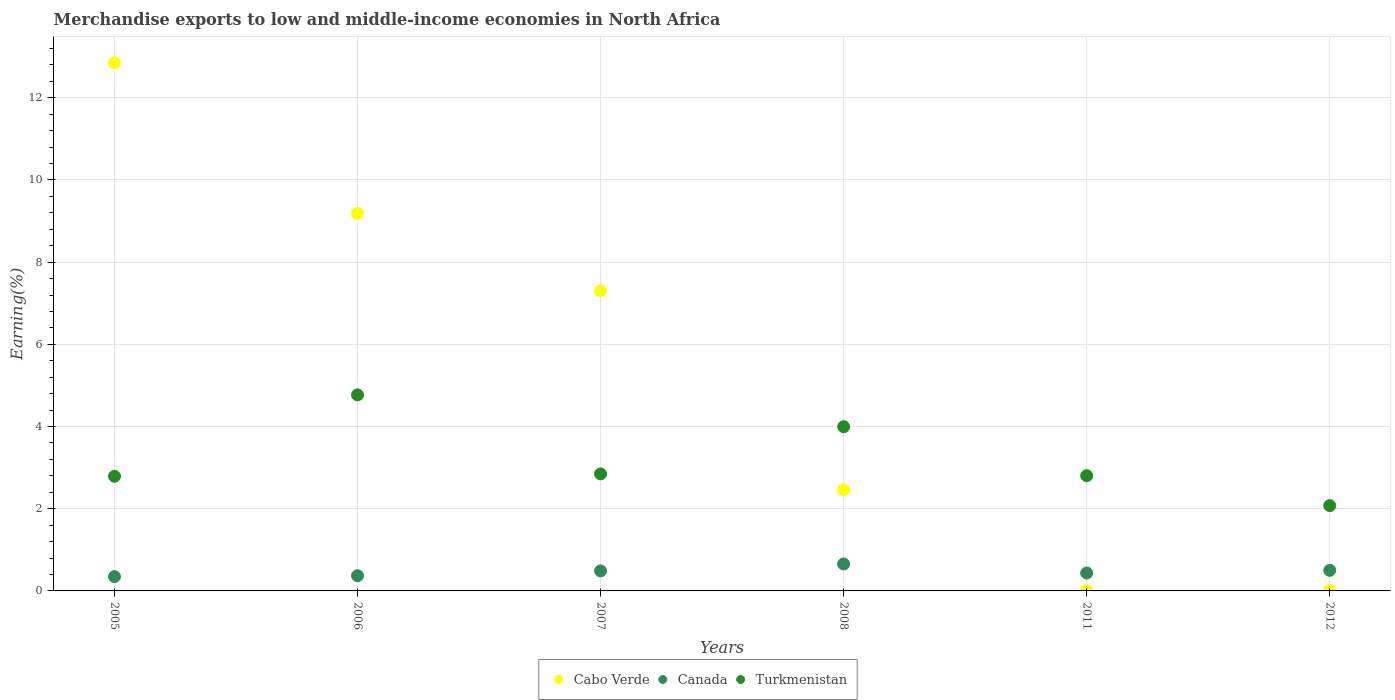How many different coloured dotlines are there?
Make the answer very short. 3. What is the percentage of amount earned from merchandise exports in Canada in 2011?
Your response must be concise. 0.44. Across all years, what is the maximum percentage of amount earned from merchandise exports in Cabo Verde?
Ensure brevity in your answer.  12.85. Across all years, what is the minimum percentage of amount earned from merchandise exports in Canada?
Offer a terse response. 0.35. What is the total percentage of amount earned from merchandise exports in Cabo Verde in the graph?
Make the answer very short. 31.82. What is the difference between the percentage of amount earned from merchandise exports in Canada in 2006 and that in 2011?
Your answer should be compact. -0.07. What is the difference between the percentage of amount earned from merchandise exports in Turkmenistan in 2005 and the percentage of amount earned from merchandise exports in Cabo Verde in 2007?
Your answer should be compact. -4.51. What is the average percentage of amount earned from merchandise exports in Cabo Verde per year?
Offer a terse response. 5.3. In the year 2005, what is the difference between the percentage of amount earned from merchandise exports in Canada and percentage of amount earned from merchandise exports in Cabo Verde?
Keep it short and to the point. -12.5. What is the ratio of the percentage of amount earned from merchandise exports in Cabo Verde in 2007 to that in 2008?
Your answer should be very brief. 2.97. What is the difference between the highest and the second highest percentage of amount earned from merchandise exports in Canada?
Your response must be concise. 0.15. What is the difference between the highest and the lowest percentage of amount earned from merchandise exports in Canada?
Make the answer very short. 0.31. In how many years, is the percentage of amount earned from merchandise exports in Cabo Verde greater than the average percentage of amount earned from merchandise exports in Cabo Verde taken over all years?
Your answer should be very brief. 3. How many years are there in the graph?
Give a very brief answer. 6. What is the difference between two consecutive major ticks on the Y-axis?
Offer a very short reply. 2. Does the graph contain any zero values?
Provide a short and direct response. No. Does the graph contain grids?
Your answer should be compact. Yes. Where does the legend appear in the graph?
Offer a very short reply. Bottom center. What is the title of the graph?
Your response must be concise. Merchandise exports to low and middle-income economies in North Africa. What is the label or title of the Y-axis?
Ensure brevity in your answer.  Earning(%). What is the Earning(%) of Cabo Verde in 2005?
Provide a succinct answer. 12.85. What is the Earning(%) in Canada in 2005?
Your answer should be compact. 0.35. What is the Earning(%) in Turkmenistan in 2005?
Make the answer very short. 2.79. What is the Earning(%) in Cabo Verde in 2006?
Provide a short and direct response. 9.18. What is the Earning(%) of Canada in 2006?
Offer a very short reply. 0.37. What is the Earning(%) in Turkmenistan in 2006?
Ensure brevity in your answer.  4.77. What is the Earning(%) in Cabo Verde in 2007?
Offer a terse response. 7.3. What is the Earning(%) of Canada in 2007?
Offer a terse response. 0.49. What is the Earning(%) of Turkmenistan in 2007?
Your response must be concise. 2.85. What is the Earning(%) in Cabo Verde in 2008?
Ensure brevity in your answer.  2.46. What is the Earning(%) of Canada in 2008?
Offer a very short reply. 0.66. What is the Earning(%) in Turkmenistan in 2008?
Give a very brief answer. 4. What is the Earning(%) in Cabo Verde in 2011?
Make the answer very short. 0.01. What is the Earning(%) in Canada in 2011?
Your answer should be compact. 0.44. What is the Earning(%) of Turkmenistan in 2011?
Offer a very short reply. 2.8. What is the Earning(%) of Cabo Verde in 2012?
Give a very brief answer. 0.01. What is the Earning(%) of Canada in 2012?
Make the answer very short. 0.5. What is the Earning(%) of Turkmenistan in 2012?
Offer a terse response. 2.08. Across all years, what is the maximum Earning(%) in Cabo Verde?
Keep it short and to the point. 12.85. Across all years, what is the maximum Earning(%) of Canada?
Give a very brief answer. 0.66. Across all years, what is the maximum Earning(%) of Turkmenistan?
Offer a terse response. 4.77. Across all years, what is the minimum Earning(%) of Cabo Verde?
Provide a succinct answer. 0.01. Across all years, what is the minimum Earning(%) in Canada?
Your response must be concise. 0.35. Across all years, what is the minimum Earning(%) in Turkmenistan?
Give a very brief answer. 2.08. What is the total Earning(%) of Cabo Verde in the graph?
Ensure brevity in your answer.  31.82. What is the total Earning(%) in Canada in the graph?
Provide a succinct answer. 2.8. What is the total Earning(%) of Turkmenistan in the graph?
Keep it short and to the point. 19.28. What is the difference between the Earning(%) of Cabo Verde in 2005 and that in 2006?
Your answer should be very brief. 3.66. What is the difference between the Earning(%) in Canada in 2005 and that in 2006?
Make the answer very short. -0.02. What is the difference between the Earning(%) in Turkmenistan in 2005 and that in 2006?
Keep it short and to the point. -1.98. What is the difference between the Earning(%) of Cabo Verde in 2005 and that in 2007?
Your answer should be compact. 5.54. What is the difference between the Earning(%) of Canada in 2005 and that in 2007?
Ensure brevity in your answer.  -0.14. What is the difference between the Earning(%) of Turkmenistan in 2005 and that in 2007?
Ensure brevity in your answer.  -0.06. What is the difference between the Earning(%) in Cabo Verde in 2005 and that in 2008?
Your response must be concise. 10.38. What is the difference between the Earning(%) of Canada in 2005 and that in 2008?
Your response must be concise. -0.31. What is the difference between the Earning(%) in Turkmenistan in 2005 and that in 2008?
Provide a short and direct response. -1.21. What is the difference between the Earning(%) in Cabo Verde in 2005 and that in 2011?
Make the answer very short. 12.84. What is the difference between the Earning(%) in Canada in 2005 and that in 2011?
Make the answer very short. -0.09. What is the difference between the Earning(%) of Turkmenistan in 2005 and that in 2011?
Ensure brevity in your answer.  -0.02. What is the difference between the Earning(%) in Cabo Verde in 2005 and that in 2012?
Offer a terse response. 12.83. What is the difference between the Earning(%) of Canada in 2005 and that in 2012?
Your answer should be very brief. -0.15. What is the difference between the Earning(%) of Turkmenistan in 2005 and that in 2012?
Give a very brief answer. 0.71. What is the difference between the Earning(%) in Cabo Verde in 2006 and that in 2007?
Provide a short and direct response. 1.88. What is the difference between the Earning(%) of Canada in 2006 and that in 2007?
Give a very brief answer. -0.12. What is the difference between the Earning(%) in Turkmenistan in 2006 and that in 2007?
Your answer should be compact. 1.92. What is the difference between the Earning(%) of Cabo Verde in 2006 and that in 2008?
Make the answer very short. 6.72. What is the difference between the Earning(%) of Canada in 2006 and that in 2008?
Your response must be concise. -0.29. What is the difference between the Earning(%) in Turkmenistan in 2006 and that in 2008?
Offer a very short reply. 0.77. What is the difference between the Earning(%) in Cabo Verde in 2006 and that in 2011?
Make the answer very short. 9.18. What is the difference between the Earning(%) in Canada in 2006 and that in 2011?
Keep it short and to the point. -0.07. What is the difference between the Earning(%) in Turkmenistan in 2006 and that in 2011?
Ensure brevity in your answer.  1.97. What is the difference between the Earning(%) of Cabo Verde in 2006 and that in 2012?
Provide a succinct answer. 9.17. What is the difference between the Earning(%) in Canada in 2006 and that in 2012?
Offer a terse response. -0.13. What is the difference between the Earning(%) in Turkmenistan in 2006 and that in 2012?
Offer a terse response. 2.69. What is the difference between the Earning(%) of Cabo Verde in 2007 and that in 2008?
Keep it short and to the point. 4.84. What is the difference between the Earning(%) in Canada in 2007 and that in 2008?
Your response must be concise. -0.17. What is the difference between the Earning(%) in Turkmenistan in 2007 and that in 2008?
Provide a short and direct response. -1.15. What is the difference between the Earning(%) of Cabo Verde in 2007 and that in 2011?
Ensure brevity in your answer.  7.29. What is the difference between the Earning(%) of Canada in 2007 and that in 2011?
Offer a very short reply. 0.05. What is the difference between the Earning(%) in Turkmenistan in 2007 and that in 2011?
Provide a short and direct response. 0.04. What is the difference between the Earning(%) of Cabo Verde in 2007 and that in 2012?
Ensure brevity in your answer.  7.29. What is the difference between the Earning(%) of Canada in 2007 and that in 2012?
Give a very brief answer. -0.01. What is the difference between the Earning(%) in Turkmenistan in 2007 and that in 2012?
Your answer should be compact. 0.77. What is the difference between the Earning(%) in Cabo Verde in 2008 and that in 2011?
Provide a short and direct response. 2.45. What is the difference between the Earning(%) in Canada in 2008 and that in 2011?
Keep it short and to the point. 0.22. What is the difference between the Earning(%) of Turkmenistan in 2008 and that in 2011?
Offer a terse response. 1.19. What is the difference between the Earning(%) in Cabo Verde in 2008 and that in 2012?
Ensure brevity in your answer.  2.45. What is the difference between the Earning(%) in Canada in 2008 and that in 2012?
Provide a succinct answer. 0.15. What is the difference between the Earning(%) in Turkmenistan in 2008 and that in 2012?
Keep it short and to the point. 1.92. What is the difference between the Earning(%) in Cabo Verde in 2011 and that in 2012?
Your response must be concise. -0.01. What is the difference between the Earning(%) of Canada in 2011 and that in 2012?
Provide a short and direct response. -0.06. What is the difference between the Earning(%) in Turkmenistan in 2011 and that in 2012?
Your response must be concise. 0.73. What is the difference between the Earning(%) in Cabo Verde in 2005 and the Earning(%) in Canada in 2006?
Provide a succinct answer. 12.48. What is the difference between the Earning(%) in Cabo Verde in 2005 and the Earning(%) in Turkmenistan in 2006?
Your answer should be very brief. 8.08. What is the difference between the Earning(%) in Canada in 2005 and the Earning(%) in Turkmenistan in 2006?
Your answer should be compact. -4.42. What is the difference between the Earning(%) of Cabo Verde in 2005 and the Earning(%) of Canada in 2007?
Provide a short and direct response. 12.36. What is the difference between the Earning(%) of Cabo Verde in 2005 and the Earning(%) of Turkmenistan in 2007?
Offer a very short reply. 10. What is the difference between the Earning(%) in Canada in 2005 and the Earning(%) in Turkmenistan in 2007?
Provide a succinct answer. -2.5. What is the difference between the Earning(%) in Cabo Verde in 2005 and the Earning(%) in Canada in 2008?
Keep it short and to the point. 12.19. What is the difference between the Earning(%) of Cabo Verde in 2005 and the Earning(%) of Turkmenistan in 2008?
Your answer should be compact. 8.85. What is the difference between the Earning(%) in Canada in 2005 and the Earning(%) in Turkmenistan in 2008?
Offer a very short reply. -3.65. What is the difference between the Earning(%) of Cabo Verde in 2005 and the Earning(%) of Canada in 2011?
Your response must be concise. 12.41. What is the difference between the Earning(%) in Cabo Verde in 2005 and the Earning(%) in Turkmenistan in 2011?
Your answer should be very brief. 10.04. What is the difference between the Earning(%) in Canada in 2005 and the Earning(%) in Turkmenistan in 2011?
Your answer should be compact. -2.46. What is the difference between the Earning(%) of Cabo Verde in 2005 and the Earning(%) of Canada in 2012?
Offer a very short reply. 12.35. What is the difference between the Earning(%) of Cabo Verde in 2005 and the Earning(%) of Turkmenistan in 2012?
Your response must be concise. 10.77. What is the difference between the Earning(%) in Canada in 2005 and the Earning(%) in Turkmenistan in 2012?
Your answer should be compact. -1.73. What is the difference between the Earning(%) of Cabo Verde in 2006 and the Earning(%) of Canada in 2007?
Offer a terse response. 8.7. What is the difference between the Earning(%) in Cabo Verde in 2006 and the Earning(%) in Turkmenistan in 2007?
Provide a succinct answer. 6.34. What is the difference between the Earning(%) of Canada in 2006 and the Earning(%) of Turkmenistan in 2007?
Provide a succinct answer. -2.48. What is the difference between the Earning(%) of Cabo Verde in 2006 and the Earning(%) of Canada in 2008?
Your response must be concise. 8.53. What is the difference between the Earning(%) in Cabo Verde in 2006 and the Earning(%) in Turkmenistan in 2008?
Give a very brief answer. 5.19. What is the difference between the Earning(%) of Canada in 2006 and the Earning(%) of Turkmenistan in 2008?
Offer a terse response. -3.63. What is the difference between the Earning(%) of Cabo Verde in 2006 and the Earning(%) of Canada in 2011?
Give a very brief answer. 8.75. What is the difference between the Earning(%) of Cabo Verde in 2006 and the Earning(%) of Turkmenistan in 2011?
Give a very brief answer. 6.38. What is the difference between the Earning(%) in Canada in 2006 and the Earning(%) in Turkmenistan in 2011?
Keep it short and to the point. -2.43. What is the difference between the Earning(%) in Cabo Verde in 2006 and the Earning(%) in Canada in 2012?
Your answer should be very brief. 8.68. What is the difference between the Earning(%) of Cabo Verde in 2006 and the Earning(%) of Turkmenistan in 2012?
Ensure brevity in your answer.  7.11. What is the difference between the Earning(%) in Canada in 2006 and the Earning(%) in Turkmenistan in 2012?
Provide a short and direct response. -1.71. What is the difference between the Earning(%) in Cabo Verde in 2007 and the Earning(%) in Canada in 2008?
Make the answer very short. 6.65. What is the difference between the Earning(%) of Cabo Verde in 2007 and the Earning(%) of Turkmenistan in 2008?
Give a very brief answer. 3.31. What is the difference between the Earning(%) of Canada in 2007 and the Earning(%) of Turkmenistan in 2008?
Offer a very short reply. -3.51. What is the difference between the Earning(%) of Cabo Verde in 2007 and the Earning(%) of Canada in 2011?
Offer a very short reply. 6.87. What is the difference between the Earning(%) of Cabo Verde in 2007 and the Earning(%) of Turkmenistan in 2011?
Your response must be concise. 4.5. What is the difference between the Earning(%) in Canada in 2007 and the Earning(%) in Turkmenistan in 2011?
Your answer should be very brief. -2.32. What is the difference between the Earning(%) in Cabo Verde in 2007 and the Earning(%) in Canada in 2012?
Offer a terse response. 6.8. What is the difference between the Earning(%) of Cabo Verde in 2007 and the Earning(%) of Turkmenistan in 2012?
Offer a very short reply. 5.23. What is the difference between the Earning(%) in Canada in 2007 and the Earning(%) in Turkmenistan in 2012?
Your response must be concise. -1.59. What is the difference between the Earning(%) of Cabo Verde in 2008 and the Earning(%) of Canada in 2011?
Keep it short and to the point. 2.03. What is the difference between the Earning(%) in Cabo Verde in 2008 and the Earning(%) in Turkmenistan in 2011?
Your answer should be very brief. -0.34. What is the difference between the Earning(%) in Canada in 2008 and the Earning(%) in Turkmenistan in 2011?
Your response must be concise. -2.15. What is the difference between the Earning(%) in Cabo Verde in 2008 and the Earning(%) in Canada in 2012?
Make the answer very short. 1.96. What is the difference between the Earning(%) of Cabo Verde in 2008 and the Earning(%) of Turkmenistan in 2012?
Ensure brevity in your answer.  0.39. What is the difference between the Earning(%) in Canada in 2008 and the Earning(%) in Turkmenistan in 2012?
Keep it short and to the point. -1.42. What is the difference between the Earning(%) in Cabo Verde in 2011 and the Earning(%) in Canada in 2012?
Offer a terse response. -0.49. What is the difference between the Earning(%) of Cabo Verde in 2011 and the Earning(%) of Turkmenistan in 2012?
Make the answer very short. -2.07. What is the difference between the Earning(%) in Canada in 2011 and the Earning(%) in Turkmenistan in 2012?
Provide a succinct answer. -1.64. What is the average Earning(%) of Cabo Verde per year?
Make the answer very short. 5.3. What is the average Earning(%) in Canada per year?
Make the answer very short. 0.47. What is the average Earning(%) of Turkmenistan per year?
Make the answer very short. 3.21. In the year 2005, what is the difference between the Earning(%) of Cabo Verde and Earning(%) of Canada?
Offer a terse response. 12.5. In the year 2005, what is the difference between the Earning(%) in Cabo Verde and Earning(%) in Turkmenistan?
Make the answer very short. 10.06. In the year 2005, what is the difference between the Earning(%) in Canada and Earning(%) in Turkmenistan?
Make the answer very short. -2.44. In the year 2006, what is the difference between the Earning(%) in Cabo Verde and Earning(%) in Canada?
Provide a succinct answer. 8.82. In the year 2006, what is the difference between the Earning(%) of Cabo Verde and Earning(%) of Turkmenistan?
Your response must be concise. 4.41. In the year 2006, what is the difference between the Earning(%) in Canada and Earning(%) in Turkmenistan?
Offer a very short reply. -4.4. In the year 2007, what is the difference between the Earning(%) in Cabo Verde and Earning(%) in Canada?
Provide a succinct answer. 6.82. In the year 2007, what is the difference between the Earning(%) in Cabo Verde and Earning(%) in Turkmenistan?
Provide a succinct answer. 4.46. In the year 2007, what is the difference between the Earning(%) in Canada and Earning(%) in Turkmenistan?
Give a very brief answer. -2.36. In the year 2008, what is the difference between the Earning(%) in Cabo Verde and Earning(%) in Canada?
Provide a succinct answer. 1.81. In the year 2008, what is the difference between the Earning(%) of Cabo Verde and Earning(%) of Turkmenistan?
Your answer should be compact. -1.53. In the year 2008, what is the difference between the Earning(%) in Canada and Earning(%) in Turkmenistan?
Offer a terse response. -3.34. In the year 2011, what is the difference between the Earning(%) of Cabo Verde and Earning(%) of Canada?
Provide a succinct answer. -0.43. In the year 2011, what is the difference between the Earning(%) of Cabo Verde and Earning(%) of Turkmenistan?
Your response must be concise. -2.8. In the year 2011, what is the difference between the Earning(%) of Canada and Earning(%) of Turkmenistan?
Your answer should be compact. -2.37. In the year 2012, what is the difference between the Earning(%) in Cabo Verde and Earning(%) in Canada?
Ensure brevity in your answer.  -0.49. In the year 2012, what is the difference between the Earning(%) in Cabo Verde and Earning(%) in Turkmenistan?
Your answer should be very brief. -2.06. In the year 2012, what is the difference between the Earning(%) in Canada and Earning(%) in Turkmenistan?
Provide a succinct answer. -1.57. What is the ratio of the Earning(%) of Cabo Verde in 2005 to that in 2006?
Your response must be concise. 1.4. What is the ratio of the Earning(%) in Canada in 2005 to that in 2006?
Offer a very short reply. 0.94. What is the ratio of the Earning(%) of Turkmenistan in 2005 to that in 2006?
Provide a succinct answer. 0.58. What is the ratio of the Earning(%) of Cabo Verde in 2005 to that in 2007?
Your response must be concise. 1.76. What is the ratio of the Earning(%) of Canada in 2005 to that in 2007?
Make the answer very short. 0.71. What is the ratio of the Earning(%) of Turkmenistan in 2005 to that in 2007?
Give a very brief answer. 0.98. What is the ratio of the Earning(%) of Cabo Verde in 2005 to that in 2008?
Provide a short and direct response. 5.22. What is the ratio of the Earning(%) of Canada in 2005 to that in 2008?
Offer a very short reply. 0.53. What is the ratio of the Earning(%) of Turkmenistan in 2005 to that in 2008?
Provide a short and direct response. 0.7. What is the ratio of the Earning(%) in Cabo Verde in 2005 to that in 2011?
Provide a succinct answer. 1542.81. What is the ratio of the Earning(%) of Canada in 2005 to that in 2011?
Offer a terse response. 0.8. What is the ratio of the Earning(%) of Cabo Verde in 2005 to that in 2012?
Give a very brief answer. 938.94. What is the ratio of the Earning(%) in Canada in 2005 to that in 2012?
Provide a short and direct response. 0.69. What is the ratio of the Earning(%) of Turkmenistan in 2005 to that in 2012?
Keep it short and to the point. 1.34. What is the ratio of the Earning(%) in Cabo Verde in 2006 to that in 2007?
Make the answer very short. 1.26. What is the ratio of the Earning(%) of Canada in 2006 to that in 2007?
Your response must be concise. 0.76. What is the ratio of the Earning(%) of Turkmenistan in 2006 to that in 2007?
Keep it short and to the point. 1.68. What is the ratio of the Earning(%) in Cabo Verde in 2006 to that in 2008?
Your answer should be very brief. 3.73. What is the ratio of the Earning(%) in Canada in 2006 to that in 2008?
Ensure brevity in your answer.  0.56. What is the ratio of the Earning(%) in Turkmenistan in 2006 to that in 2008?
Give a very brief answer. 1.19. What is the ratio of the Earning(%) in Cabo Verde in 2006 to that in 2011?
Provide a succinct answer. 1103.05. What is the ratio of the Earning(%) of Canada in 2006 to that in 2011?
Offer a very short reply. 0.85. What is the ratio of the Earning(%) of Turkmenistan in 2006 to that in 2011?
Offer a terse response. 1.7. What is the ratio of the Earning(%) of Cabo Verde in 2006 to that in 2012?
Provide a succinct answer. 671.31. What is the ratio of the Earning(%) in Canada in 2006 to that in 2012?
Offer a terse response. 0.74. What is the ratio of the Earning(%) of Turkmenistan in 2006 to that in 2012?
Your answer should be compact. 2.3. What is the ratio of the Earning(%) in Cabo Verde in 2007 to that in 2008?
Ensure brevity in your answer.  2.97. What is the ratio of the Earning(%) of Canada in 2007 to that in 2008?
Offer a very short reply. 0.74. What is the ratio of the Earning(%) in Turkmenistan in 2007 to that in 2008?
Give a very brief answer. 0.71. What is the ratio of the Earning(%) of Cabo Verde in 2007 to that in 2011?
Provide a short and direct response. 877.03. What is the ratio of the Earning(%) in Canada in 2007 to that in 2011?
Make the answer very short. 1.12. What is the ratio of the Earning(%) of Turkmenistan in 2007 to that in 2011?
Offer a terse response. 1.02. What is the ratio of the Earning(%) in Cabo Verde in 2007 to that in 2012?
Ensure brevity in your answer.  533.76. What is the ratio of the Earning(%) in Canada in 2007 to that in 2012?
Your answer should be compact. 0.97. What is the ratio of the Earning(%) of Turkmenistan in 2007 to that in 2012?
Your answer should be compact. 1.37. What is the ratio of the Earning(%) of Cabo Verde in 2008 to that in 2011?
Your answer should be very brief. 295.77. What is the ratio of the Earning(%) in Canada in 2008 to that in 2011?
Keep it short and to the point. 1.5. What is the ratio of the Earning(%) of Turkmenistan in 2008 to that in 2011?
Your answer should be very brief. 1.42. What is the ratio of the Earning(%) of Cabo Verde in 2008 to that in 2012?
Offer a very short reply. 180. What is the ratio of the Earning(%) in Canada in 2008 to that in 2012?
Give a very brief answer. 1.31. What is the ratio of the Earning(%) in Turkmenistan in 2008 to that in 2012?
Give a very brief answer. 1.92. What is the ratio of the Earning(%) in Cabo Verde in 2011 to that in 2012?
Provide a succinct answer. 0.61. What is the ratio of the Earning(%) of Canada in 2011 to that in 2012?
Your answer should be very brief. 0.87. What is the ratio of the Earning(%) of Turkmenistan in 2011 to that in 2012?
Make the answer very short. 1.35. What is the difference between the highest and the second highest Earning(%) in Cabo Verde?
Ensure brevity in your answer.  3.66. What is the difference between the highest and the second highest Earning(%) of Canada?
Your answer should be very brief. 0.15. What is the difference between the highest and the second highest Earning(%) in Turkmenistan?
Ensure brevity in your answer.  0.77. What is the difference between the highest and the lowest Earning(%) in Cabo Verde?
Provide a succinct answer. 12.84. What is the difference between the highest and the lowest Earning(%) of Canada?
Provide a succinct answer. 0.31. What is the difference between the highest and the lowest Earning(%) in Turkmenistan?
Provide a short and direct response. 2.69. 